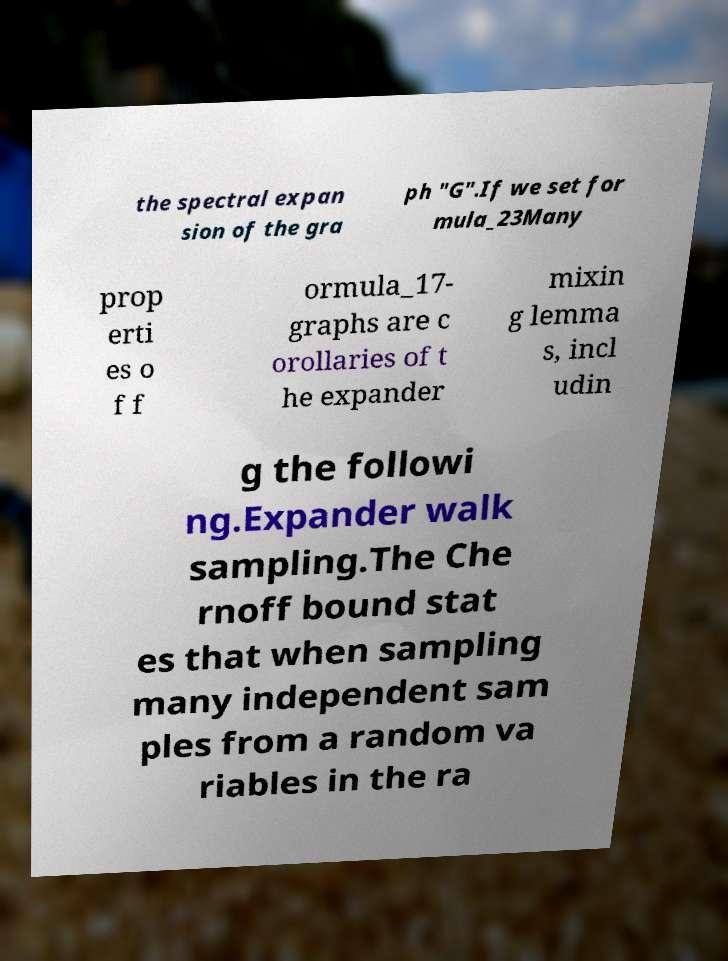Can you accurately transcribe the text from the provided image for me? the spectral expan sion of the gra ph "G".If we set for mula_23Many prop erti es o f f ormula_17- graphs are c orollaries of t he expander mixin g lemma s, incl udin g the followi ng.Expander walk sampling.The Che rnoff bound stat es that when sampling many independent sam ples from a random va riables in the ra 